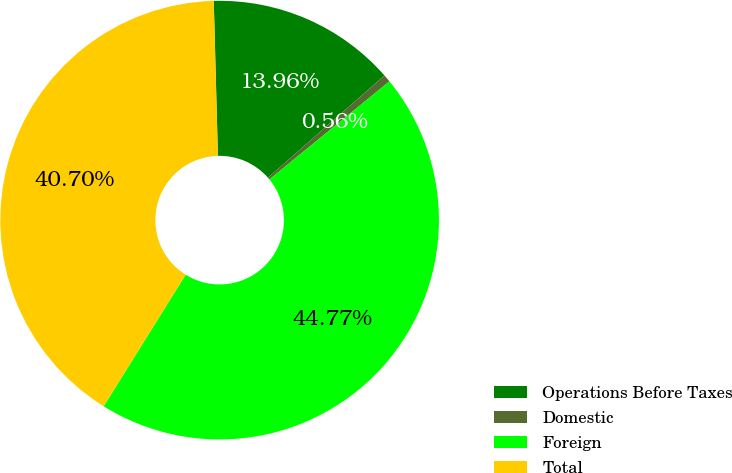<chart> <loc_0><loc_0><loc_500><loc_500><pie_chart><fcel>Operations Before Taxes<fcel>Domestic<fcel>Foreign<fcel>Total<nl><fcel>13.96%<fcel>0.56%<fcel>44.77%<fcel>40.7%<nl></chart> 